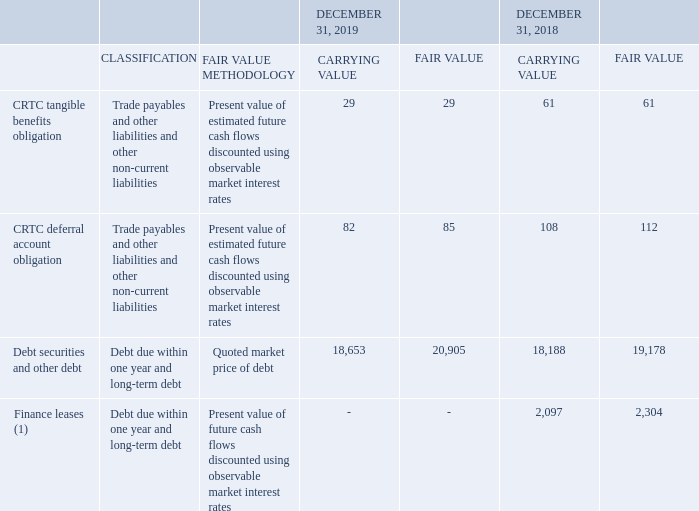FAIR VALUE
Fair value is the price that would be received to sell an asset or paid to transfer a liability in an orderly transaction between market participants at the measurement date.
Certain fair value estimates are affected by assumptions we make about the amount and timing of future cash flows and discount rates, all of which reflect varying degrees of risk. Income taxes and other expenses that would be incurred on disposition of financial instruments are not reflected in the fair values. As a result, the fair values are not the net amounts that would be realized if these instruments were settled.
The carrying values of our cash and cash equivalents, trade and other receivables, dividends payable, trade payables and accruals, compensation payable, severance and other costs payable, interest payable, notes payable and loans secured by trade receivables approximate fair value as they are short-term.
The following table provides the fair value details of financial instruments measured at amortized cost in the statements of financial position.
(1) Upon adoption of IFRS 16 on January 1, 2019, fair value disclosures are no longer required for leases
What is fair value? The price that would be received to sell an asset or paid to transfer a liability in an orderly transaction between market participants at the measurement date. What is the fair value methodology for debt securities and other debt? Quoted market price of debt. Which segments approximate fair value as they are short-term? The carrying values of our cash and cash equivalents, trade and other receivables, dividends payable, trade payables and accruals, compensation payable, severance and other costs payable, interest payable, notes payable and loans secured by trade receivables. What is the percentage change in carrying values for CRTC deferral account obligation in 2019?
Answer scale should be: percent. (82-108)/108
Answer: -24.07. What is the percentage change in fair values for CRTC tangible benefits obligation in 2019?
Answer scale should be: percent. (29-61)/61
Answer: -52.46. What is the sum of carrying values in 2019? 29+82+18,653
Answer: 18764. 